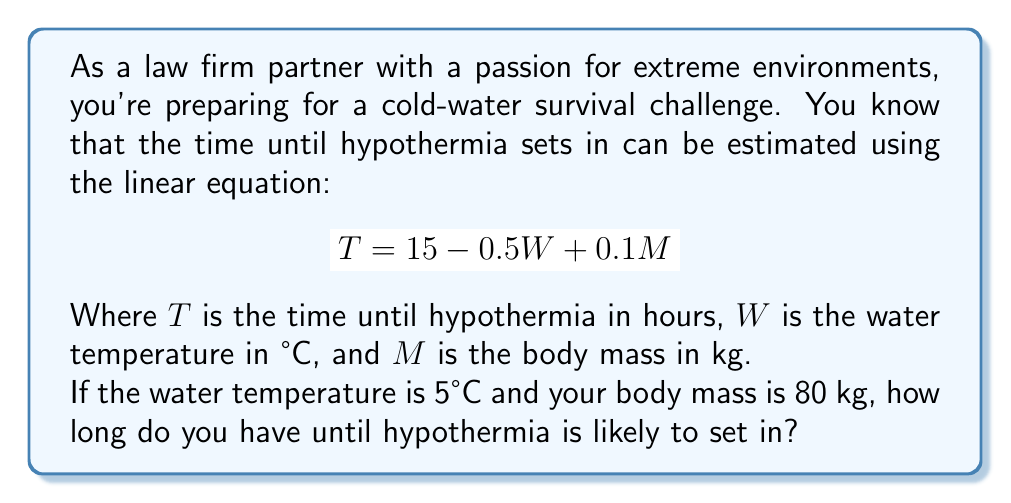Help me with this question. To solve this problem, we'll use the given linear equation and substitute the known values:

$$T = 15 - 0.5W + 0.1M$$

Where:
$W = 5°C$ (water temperature)
$M = 80 kg$ (body mass)

Let's substitute these values into the equation:

$$\begin{align}
T &= 15 - 0.5(5) + 0.1(80) \\
&= 15 - 2.5 + 8 \\
&= 12.5 + 8 \\
&= 20.5
\end{align}$$

Therefore, the time until hypothermia is likely to set in is 20.5 hours.
Answer: 20.5 hours 